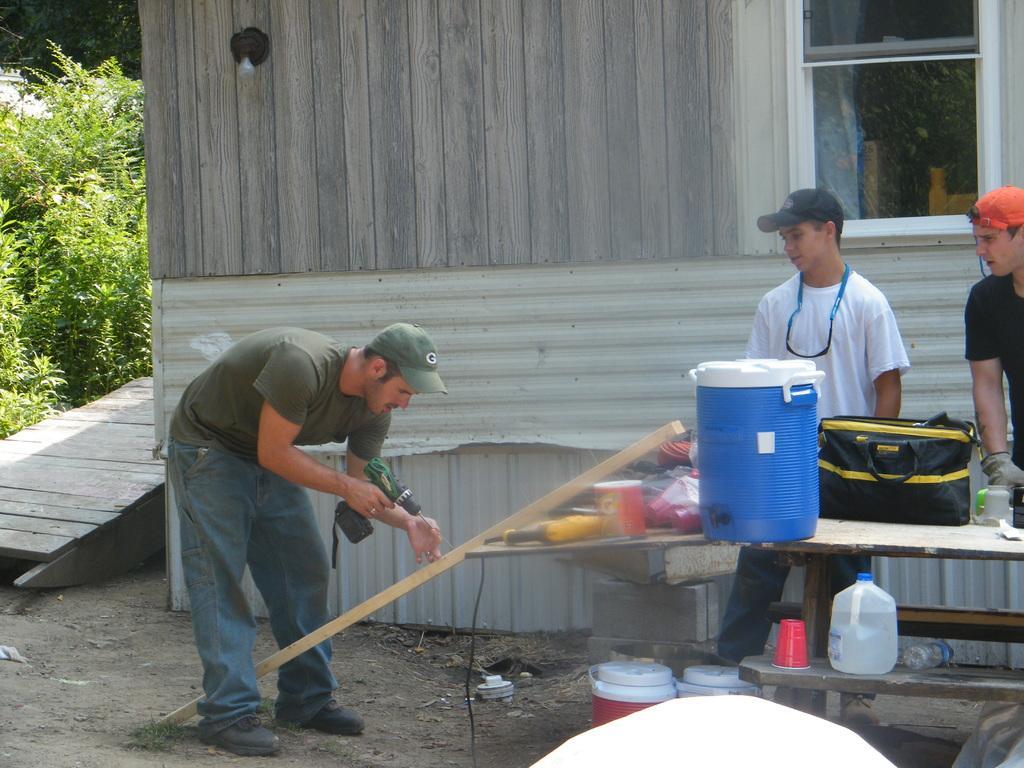Please provide a concise description of this image. In this image I can see three men and I can see all of them are wearing t shirts and caps. Here I can see he is holding a drill machine. I can also see a table and on it I can see a bag, a bottle, a glass and I can also see few water campers over here. In the background I can see a house and bushes. 